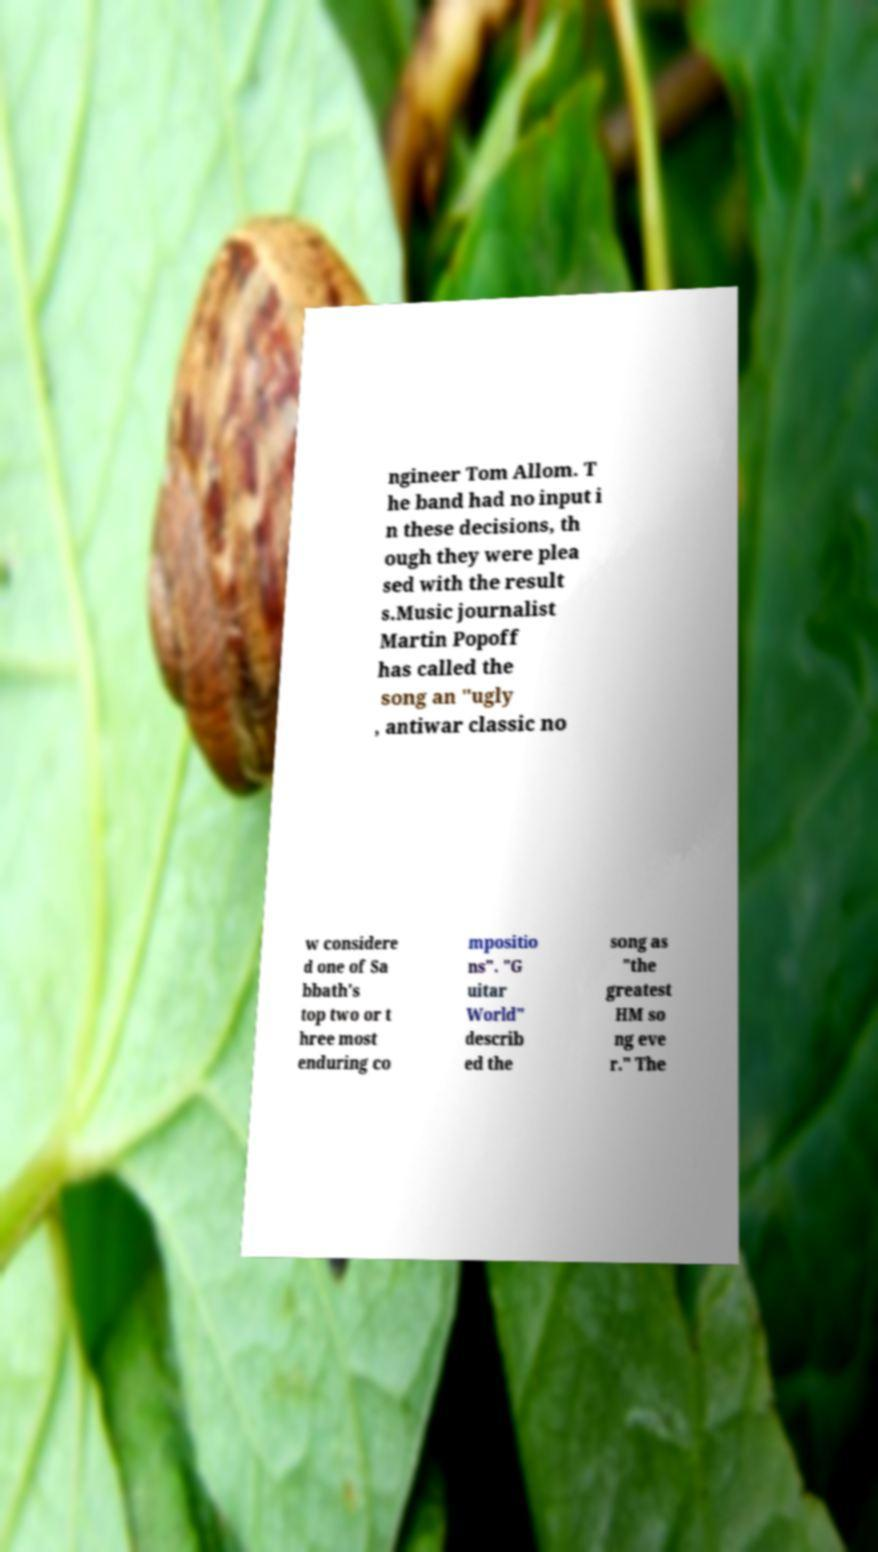I need the written content from this picture converted into text. Can you do that? ngineer Tom Allom. T he band had no input i n these decisions, th ough they were plea sed with the result s.Music journalist Martin Popoff has called the song an "ugly , antiwar classic no w considere d one of Sa bbath's top two or t hree most enduring co mpositio ns". "G uitar World" describ ed the song as "the greatest HM so ng eve r." The 